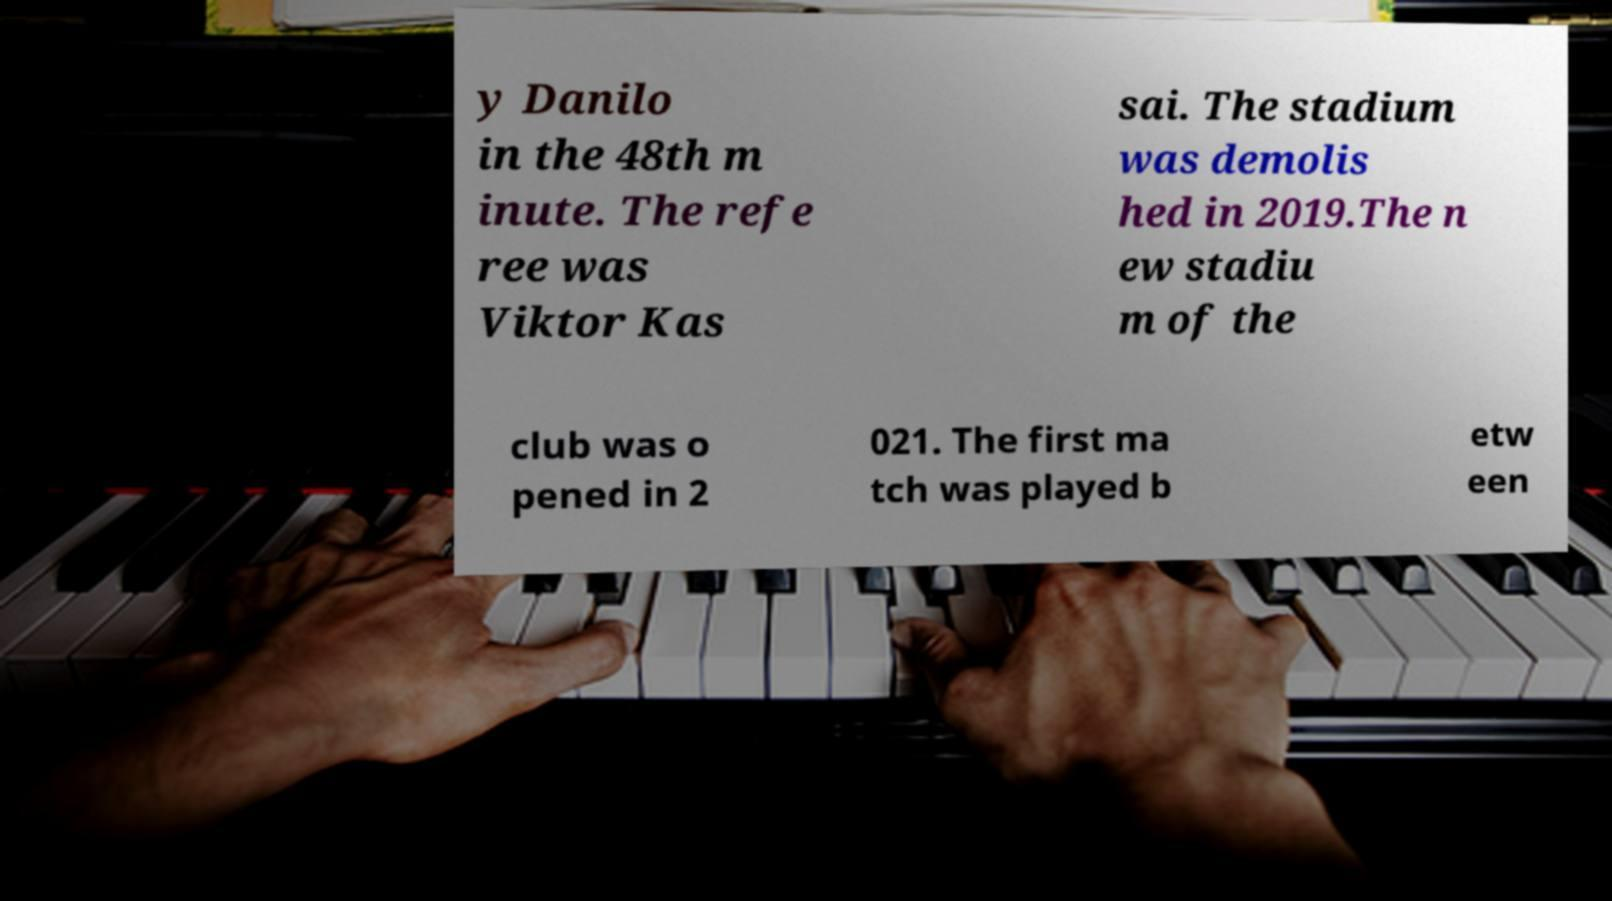There's text embedded in this image that I need extracted. Can you transcribe it verbatim? y Danilo in the 48th m inute. The refe ree was Viktor Kas sai. The stadium was demolis hed in 2019.The n ew stadiu m of the club was o pened in 2 021. The first ma tch was played b etw een 